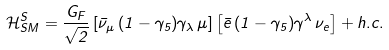<formula> <loc_0><loc_0><loc_500><loc_500>\mathcal { H } _ { S M } ^ { S } = \frac { G _ { F } } { \sqrt { 2 } } \left [ \bar { \nu } _ { \mu } \, ( 1 - \gamma _ { 5 } ) \gamma _ { \lambda } \, \mu \right ] \left [ \bar { e } \, ( 1 - \gamma _ { 5 } ) \gamma ^ { \lambda } \, \nu _ { e } \right ] + h . c .</formula> 